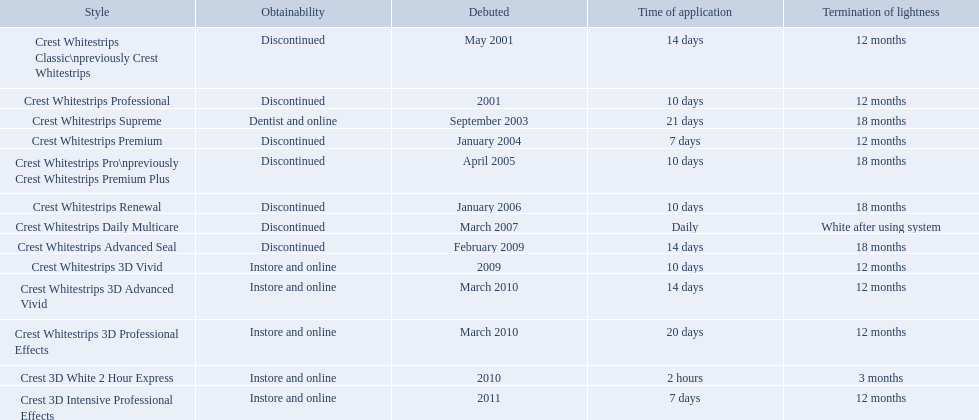What are all the models? Crest Whitestrips Classic\npreviously Crest Whitestrips, Crest Whitestrips Professional, Crest Whitestrips Supreme, Crest Whitestrips Premium, Crest Whitestrips Pro\npreviously Crest Whitestrips Premium Plus, Crest Whitestrips Renewal, Crest Whitestrips Daily Multicare, Crest Whitestrips Advanced Seal, Crest Whitestrips 3D Vivid, Crest Whitestrips 3D Advanced Vivid, Crest Whitestrips 3D Professional Effects, Crest 3D White 2 Hour Express, Crest 3D Intensive Professional Effects. Of these, for which can a ratio be calculated for 'length of use' to 'last of whiteness'? Crest Whitestrips Classic\npreviously Crest Whitestrips, Crest Whitestrips Professional, Crest Whitestrips Supreme, Crest Whitestrips Premium, Crest Whitestrips Pro\npreviously Crest Whitestrips Premium Plus, Crest Whitestrips Renewal, Crest Whitestrips Advanced Seal, Crest Whitestrips 3D Vivid, Crest Whitestrips 3D Advanced Vivid, Crest Whitestrips 3D Professional Effects, Crest 3D White 2 Hour Express, Crest 3D Intensive Professional Effects. Which has the highest ratio? Crest Whitestrips Supreme. 